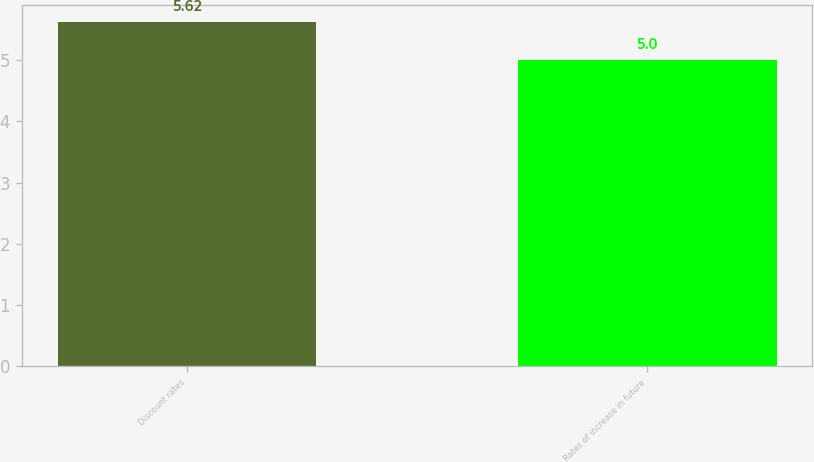<chart> <loc_0><loc_0><loc_500><loc_500><bar_chart><fcel>Discount rates<fcel>Rates of increase in future<nl><fcel>5.62<fcel>5<nl></chart> 